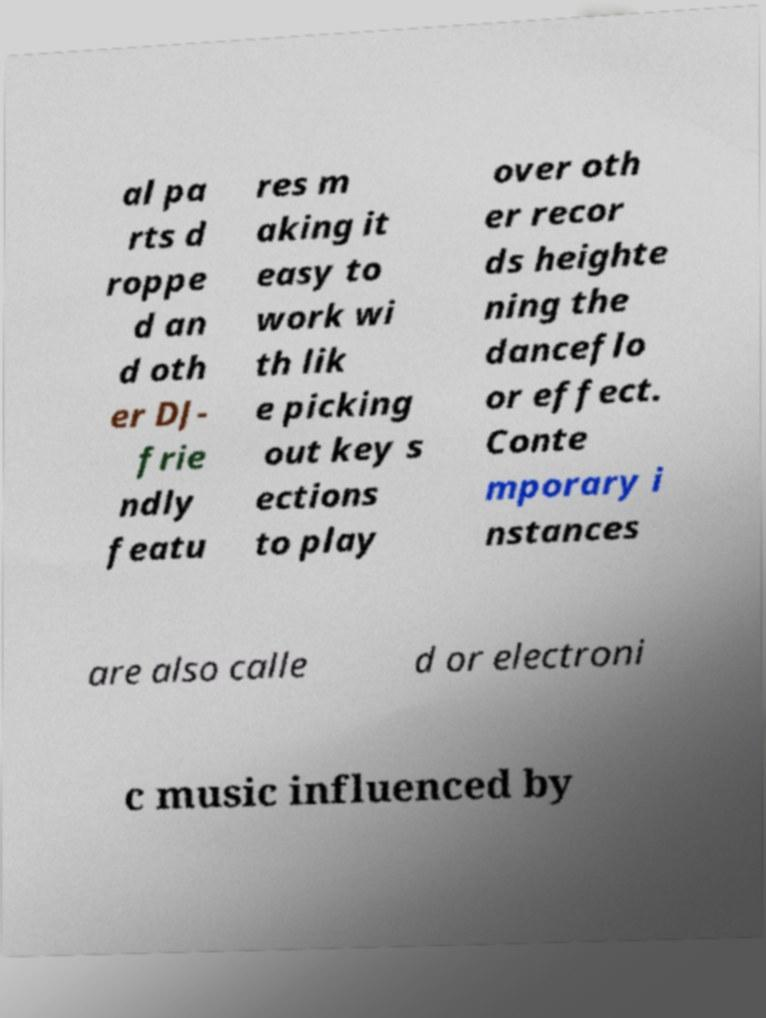Could you assist in decoding the text presented in this image and type it out clearly? al pa rts d roppe d an d oth er DJ- frie ndly featu res m aking it easy to work wi th lik e picking out key s ections to play over oth er recor ds heighte ning the danceflo or effect. Conte mporary i nstances are also calle d or electroni c music influenced by 